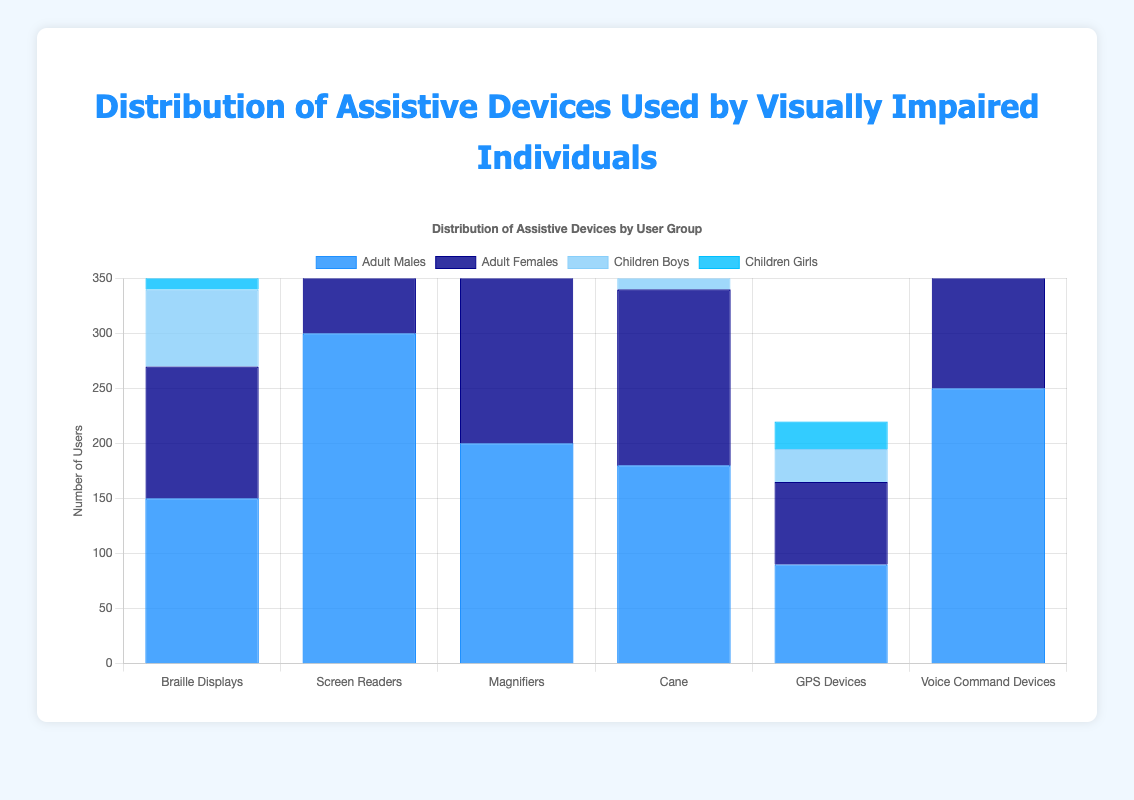What assistive device has the highest number of adult male users? According to the bar chart, the tallest bar for Adult Males is for Screen Readers, indicating that more adult males use Screen Readers compared to other assistive devices.
Answer: Screen Readers Which assistive device has an equal number of users among adult males and adult females? By comparing the height of the bars, Voice Command Devices have almost equal height for Adult Males (250) and Adult Females (240).
Answer: Voice Command Devices Which group uses magnifiers more: Adult Females or Children Boys? From the bar chart, the bar for Adult Females for Magnifiers is noticeably taller than the bar for Children Boys. Adult Females have 220 users and Children Boys have 60 users.
Answer: Adult Females What is the combined total number of users (all groups) for Braille Displays? Adding the number of users for each group using Braille Displays: 150 (Adult Males) + 120 (Adult Females) + 70 (Children Boys) + 80 (Children Girls) equals 420 users.
Answer: 420 Which device do children girls use the least? Looking at the bars for Children Girls, the shortest bar is for GPS Devices, indicating that it is the least used device among Children Girls with 25 users.
Answer: GPS Devices Compare the number of adult females using magnifiers and canes. Which is higher and by how much? From the chart, Adult Females using Magnifiers is 220, and those using Canes are 160. The difference can be calculated as 220 - 160 = 60.
Answer: Magnifiers, by 60 What is the average number of users of Voice Command Devices among the four groups? Sum the number of users for Voice Command Devices: 250 (Adult Males) + 240 (Adult Females) + 100 (Children Boys) + 95 (Children Girls) equals 685. Dividing by 4 groups, 685 / 4 equals approximately 171.25 users.
Answer: 171.25 Among adult females, which is the second most used device after Screen Readers? Observing the bars for Adult Females, Screen Readers have the highest number. The next highest bar is for Voice Command Devices.
Answer: Voice Command Devices What is the difference between the total number of children boys who use Canes and the total number of adult females who use GPS Devices? From the chart, children boys using Canes are 50, and adult females using GPS Devices are 75. The difference is calculated as 75 - 50 = 25.
Answer: 25 Which device has the smallest discrepancy in usage between boys and girls? By comparing the height of the bars for children boys and girls across all devices, Magnifiers have a small difference: 60 for boys and 70 for girls, giving a discrepancy of 10.
Answer: Magnifiers 